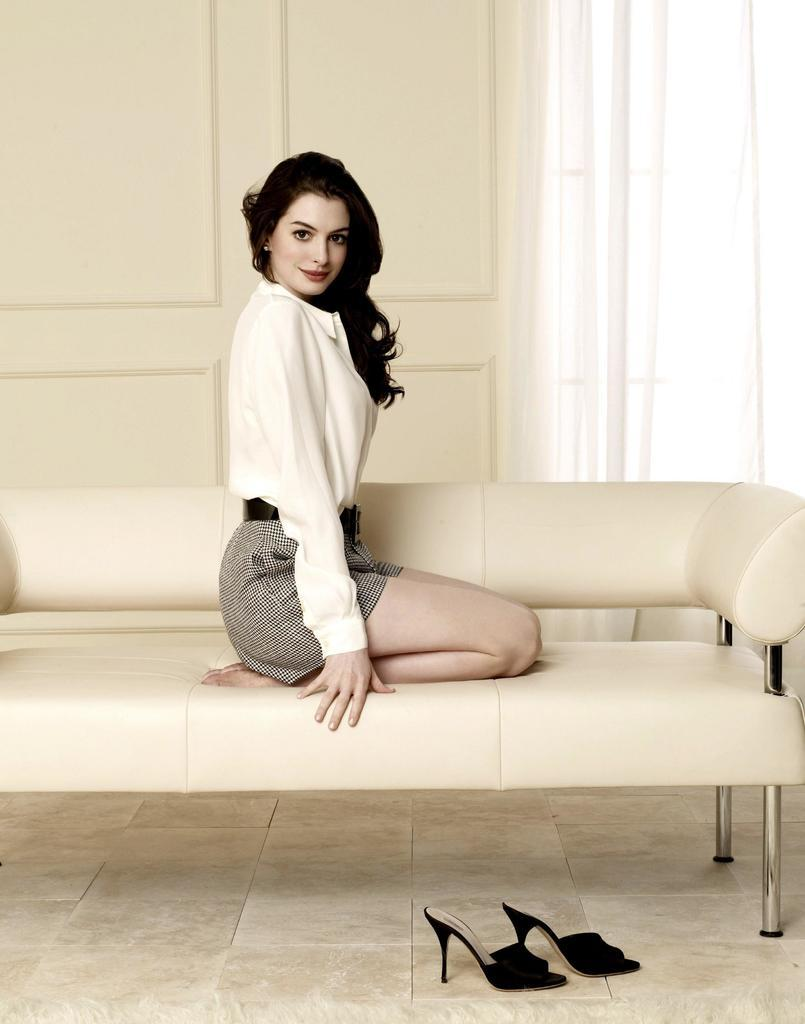What is the woman in the image doing? The woman is sitting on the couch. What type of footwear can be seen on the floor? There are heels placed on the floor. What can be seen in the background of the image? There is a door and a curtain hanging in the background. What type of disease is the woman suffering from in the image? There is no indication in the image that the woman is suffering from any disease. 